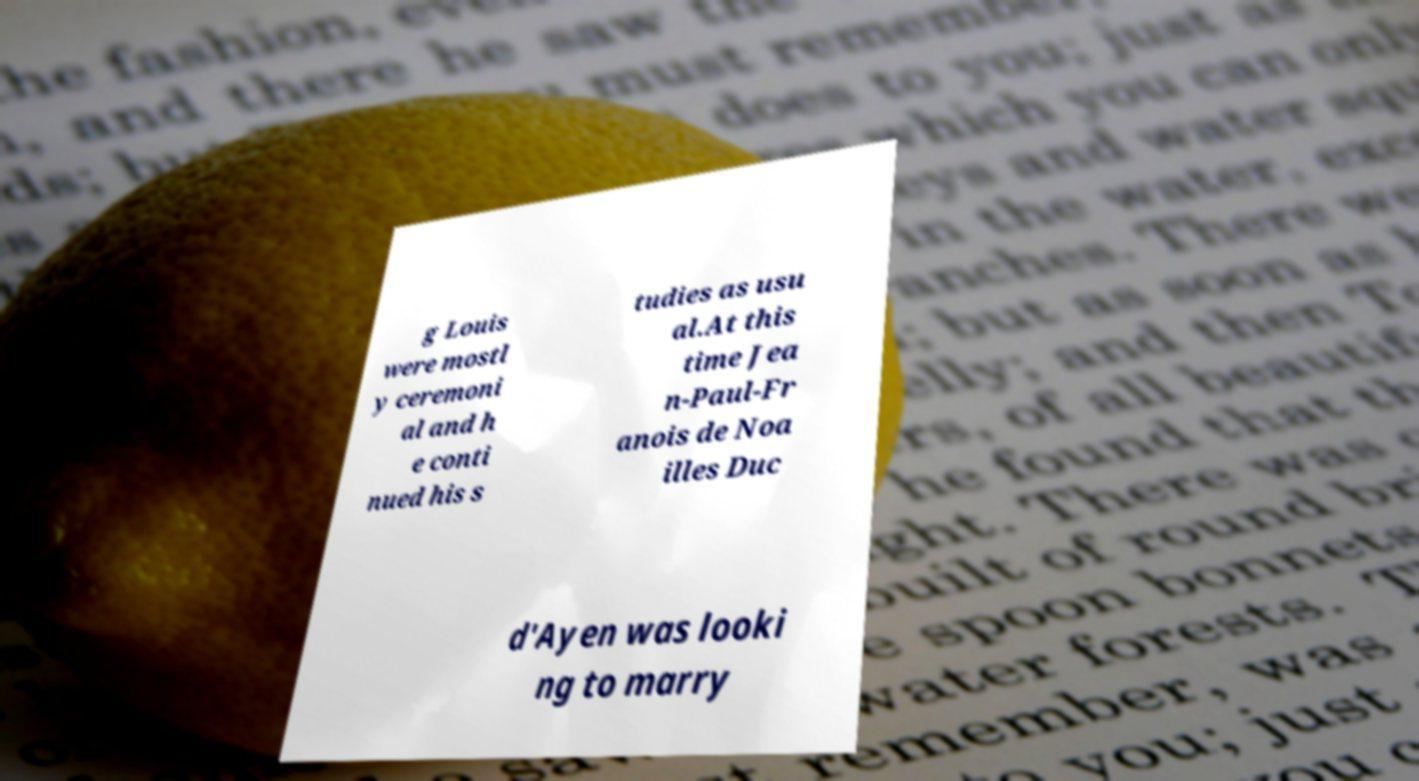For documentation purposes, I need the text within this image transcribed. Could you provide that? g Louis were mostl y ceremoni al and h e conti nued his s tudies as usu al.At this time Jea n-Paul-Fr anois de Noa illes Duc d'Ayen was looki ng to marry 